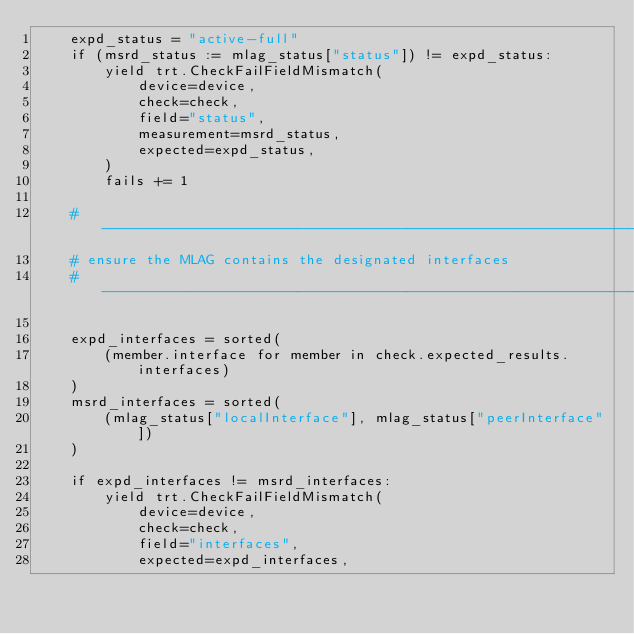<code> <loc_0><loc_0><loc_500><loc_500><_Python_>    expd_status = "active-full"
    if (msrd_status := mlag_status["status"]) != expd_status:
        yield trt.CheckFailFieldMismatch(
            device=device,
            check=check,
            field="status",
            measurement=msrd_status,
            expected=expd_status,
        )
        fails += 1

    # -------------------------------------------------------------------------
    # ensure the MLAG contains the designated interfaces
    # -------------------------------------------------------------------------

    expd_interfaces = sorted(
        (member.interface for member in check.expected_results.interfaces)
    )
    msrd_interfaces = sorted(
        (mlag_status["localInterface"], mlag_status["peerInterface"])
    )

    if expd_interfaces != msrd_interfaces:
        yield trt.CheckFailFieldMismatch(
            device=device,
            check=check,
            field="interfaces",
            expected=expd_interfaces,</code> 